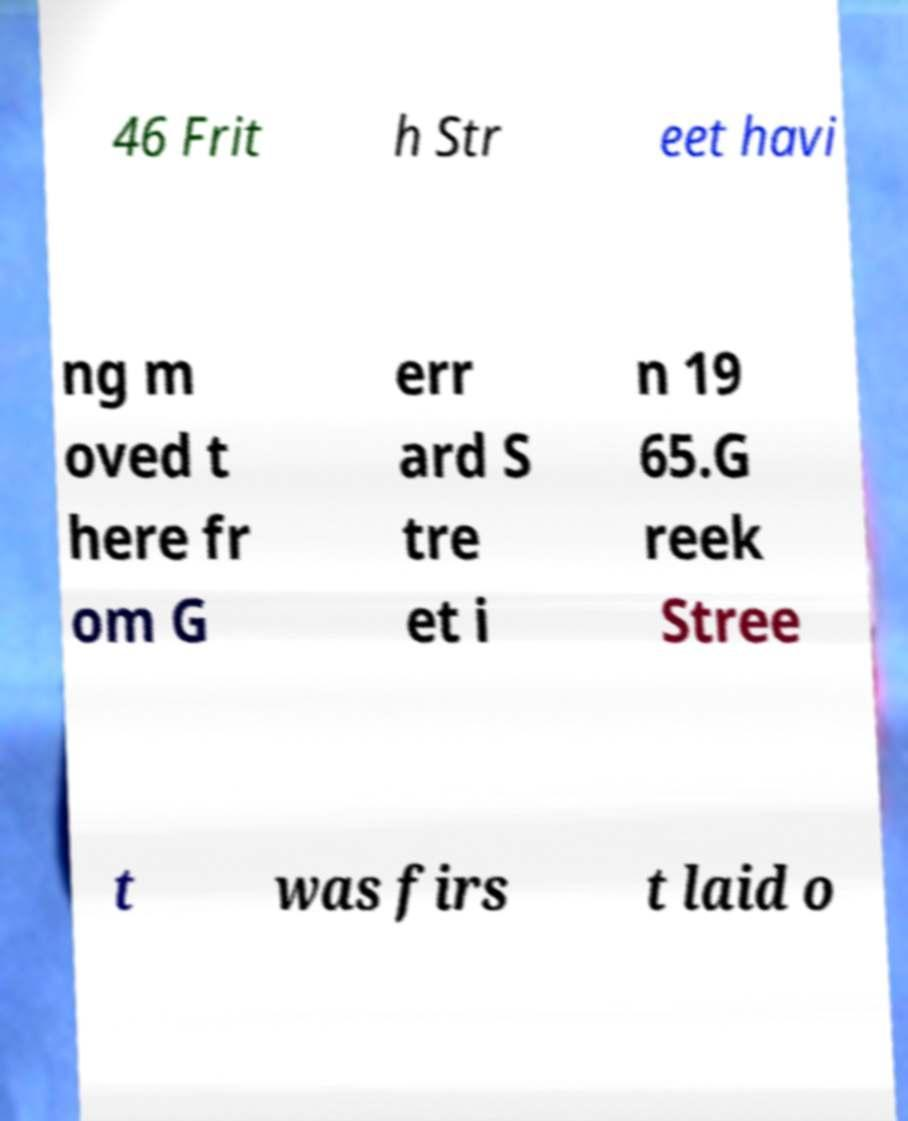What messages or text are displayed in this image? I need them in a readable, typed format. 46 Frit h Str eet havi ng m oved t here fr om G err ard S tre et i n 19 65.G reek Stree t was firs t laid o 